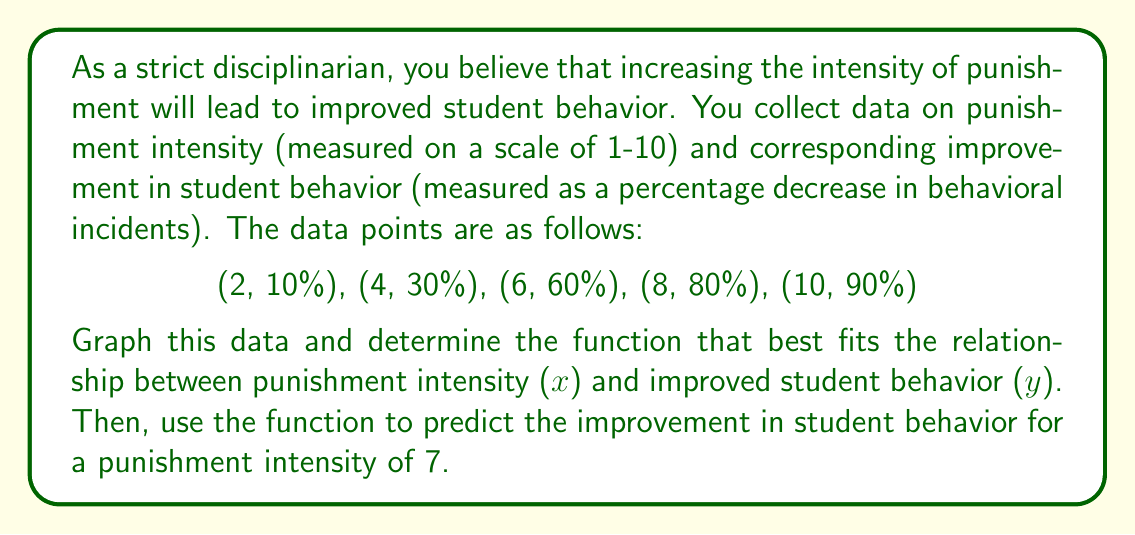Help me with this question. To solve this problem, we'll follow these steps:

1) First, let's plot the given data points on a coordinate plane.

[asy]
size(200,200);
import graph;

real[] x = {2,4,6,8,10};
real[] y = {10,30,60,80,90};

for(int i=0; i < x.length; ++i) {
  dot((x[i],y[i]));
}

xaxis("Punishment Intensity",0,11,arrow=Arrow);
yaxis("Behavior Improvement (%)",0,100,arrow=Arrow);

label("(2,10)",(2,10),SE);
label("(4,30)",(4,30),SE);
label("(6,60)",(6,60),NW);
label("(8,80)",(8,80),SW);
label("(10,90)",(10,90),SW);
[/asy]

2) Looking at the graph, we can see that the relationship is not linear. The improvement in behavior increases rapidly at first but then starts to level off. This suggests a logarithmic function.

3) The general form of a logarithmic function is:

   $$ y = a \ln(x) + b $$

   where $a$ and $b$ are constants we need to determine.

4) We can use two points to solve for $a$ and $b$. Let's use (2, 10) and (10, 90):

   $$ 10 = a \ln(2) + b $$
   $$ 90 = a \ln(10) + b $$

5) Subtracting the first equation from the second:

   $$ 80 = a(\ln(10) - \ln(2)) $$
   $$ 80 = a \ln(5) $$
   $$ a = \frac{80}{\ln(5)} \approx 49.72 $$

6) Now we can substitute this back into either of the original equations to find $b$:

   $$ 10 = 49.72 \ln(2) + b $$
   $$ b = 10 - 49.72 \ln(2) \approx -24.46 $$

7) Therefore, our function is:

   $$ y = 49.72 \ln(x) - 24.46 $$

8) To predict the improvement for a punishment intensity of 7, we substitute $x=7$ into our function:

   $$ y = 49.72 \ln(7) - 24.46 \approx 71.54 $$
Answer: The function that best fits the data is $y = 49.72 \ln(x) - 24.46$, where $x$ is the punishment intensity and $y$ is the percentage improvement in student behavior. For a punishment intensity of 7, the predicted improvement in student behavior is approximately 71.54%. 